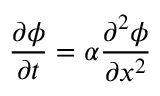Convert formula to latex. <formula><loc_0><loc_0><loc_500><loc_500>\frac { \partial \phi } { \partial t } = \alpha \frac { \partial ^ { 2 } \phi } { \partial x ^ { 2 } }</formula> 